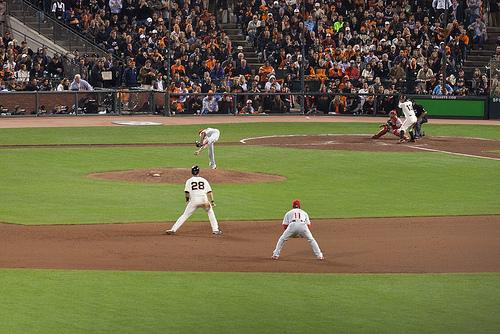Can you describe the scene in the image, mentioning some key objects or elements? A baseball game is taking place with players in position, wearing white uniforms, red and black helmets, and protective gear. The pitch is about to be thrown as the umpire crouches behind the catcher, and fans watch from the bleachers. Which two players' helmets are mentioned in the image description, and what colors are they? The baseball player wearing a red cap and the player wearing a black safety helmet are mentioned in the image description. What is the basic layout and features of the image in terms of the baseball field and the audience area? The baseball field has a pitchers mound, green grass, brown dirt, and a solid white line. The audience area features a gray fence, a stairway, and fans sitting in the bleachers. What can you gather about the event taking place in this image? A baseball game is occurring, with players in various positions such as pitcher, batter, catcher, and shortstop, and fans watching from the bleachers. How many players are wearing white uniforms, and what numbers can be seen on their jerseys? Four players wear white uniforms with numbers 11 and 28 visible on their jerseys. As per the image information, name a few objects present in the image related to the game of baseball. Objects related to the game of baseball present in the image include a baseball field, a pitcher's mound, helmets, uniforms with numbers, a gray fence, and spectators in the bleachers. In what position is the umpire, and what color is the shirt on a person mentioned in the image? The umpire is crouched, and an orange shirt is mentioned on a person in the image. Enumerate three distinct features of the baseball players' uniforms. Three features of the uniforms are: red and black helmets, white uniforms with numbers 11 and 28 in red and black, and respective protective gear for each position. Describe the primary features of the image related to the field and the audience. The image features a baseball field with green grass, brown dirt, a pitcher's mound, and a solid white line. There's a gray fence, a stairway, and a group of fans in the audience. In this image, how many different numbered players are mentioned, and what are those numbers? Two different numbered players are mentioned in the image: number 11 and number 28. What is the batter in position to do? hit a ball Find the large scoreboard in the background and read the current score of the game. No, it's not mentioned in the image. Describe the scene in terms of people, objects, and activity. people playing baseball, spectators in the stands, pitcher throwing ball, batter ready to swing What color of safety helmet is being worn by one of the players? black What is the main event happening in the image? people playing baseball What is the location of the stairway in relation to the image? at a stadium List the visible numbers on the players' shirts along with their colors. number 11 in red, number 28 in black Describe the position of the umpire in relation to the catcher. umpire is standing behind the catcher Which object is being thrown by the pitcher? ball What is the layout of the scene in terms of the positions occupied by the pitcher, batter, catcher, and umpire? pitcher throwing ball, batter ready to swing, catcher squatting behind batter, umpire standing behind catcher Which player is squatting down in the image? a catcher How many players are wearing white uniforms? four What color is the shirt with number 28 printed on it? white In the image, what objectType is protecting the dugout? gray fence Identify the type of fence in the image. chain link fence Which player is ready to swing? batter Find the color of the cap worn by the baseball player. red Who is leading off of second base in the image? man How are the fans spending their time in the bleachers? sitting and watching the game Identify the color of the shirt worn by a person with an orange shirt. orange 